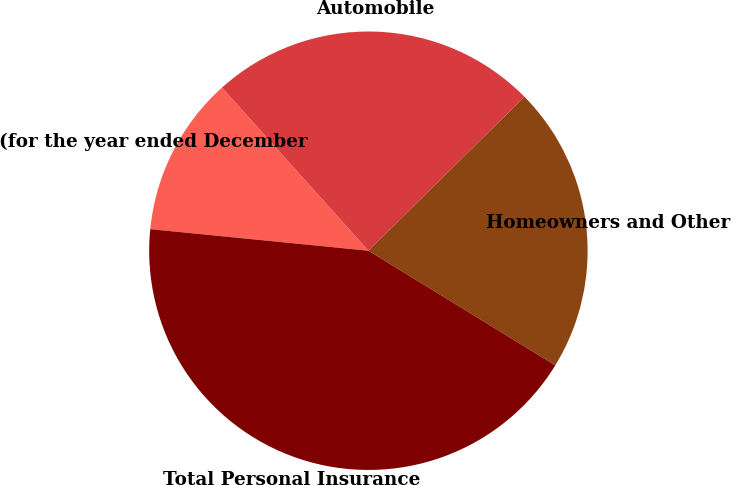<chart> <loc_0><loc_0><loc_500><loc_500><pie_chart><fcel>(for the year ended December<fcel>Automobile<fcel>Homeowners and Other<fcel>Total Personal Insurance<nl><fcel>11.79%<fcel>24.25%<fcel>21.15%<fcel>42.81%<nl></chart> 